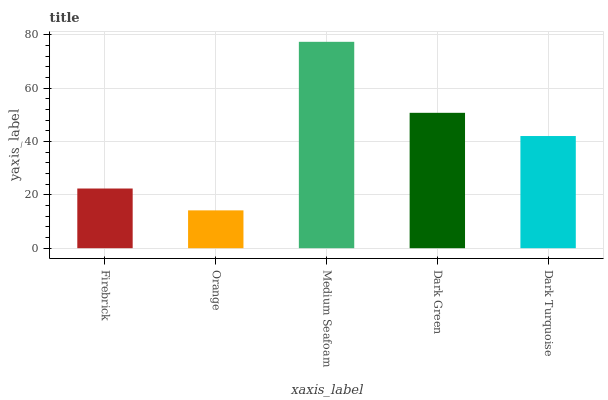Is Medium Seafoam the minimum?
Answer yes or no. No. Is Orange the maximum?
Answer yes or no. No. Is Medium Seafoam greater than Orange?
Answer yes or no. Yes. Is Orange less than Medium Seafoam?
Answer yes or no. Yes. Is Orange greater than Medium Seafoam?
Answer yes or no. No. Is Medium Seafoam less than Orange?
Answer yes or no. No. Is Dark Turquoise the high median?
Answer yes or no. Yes. Is Dark Turquoise the low median?
Answer yes or no. Yes. Is Firebrick the high median?
Answer yes or no. No. Is Firebrick the low median?
Answer yes or no. No. 